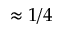Convert formula to latex. <formula><loc_0><loc_0><loc_500><loc_500>\approx 1 / 4</formula> 